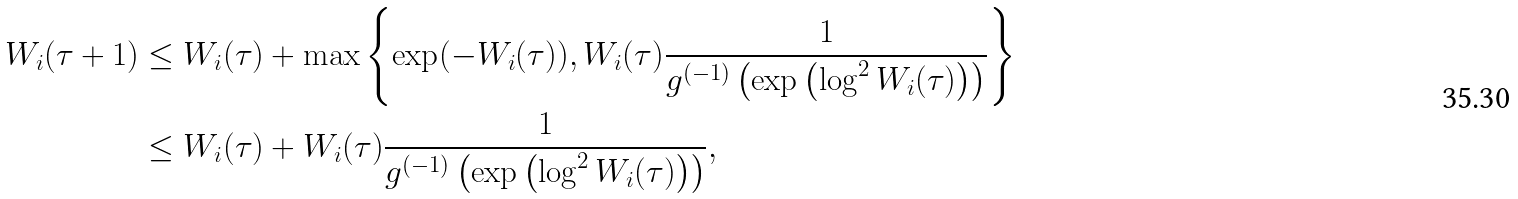<formula> <loc_0><loc_0><loc_500><loc_500>W _ { i } ( \tau + 1 ) & \leq W _ { i } ( \tau ) + \max \left \{ \exp ( - W _ { i } ( \tau ) ) , W _ { i } ( \tau ) \frac { 1 } { g ^ { ( - 1 ) } \left ( \exp \left ( \log ^ { 2 } W _ { i } ( \tau ) \right ) \right ) } \right \} \\ & \leq W _ { i } ( \tau ) + W _ { i } ( \tau ) \frac { 1 } { g ^ { ( - 1 ) } \left ( \exp \left ( \log ^ { 2 } W _ { i } ( \tau ) \right ) \right ) } ,</formula> 